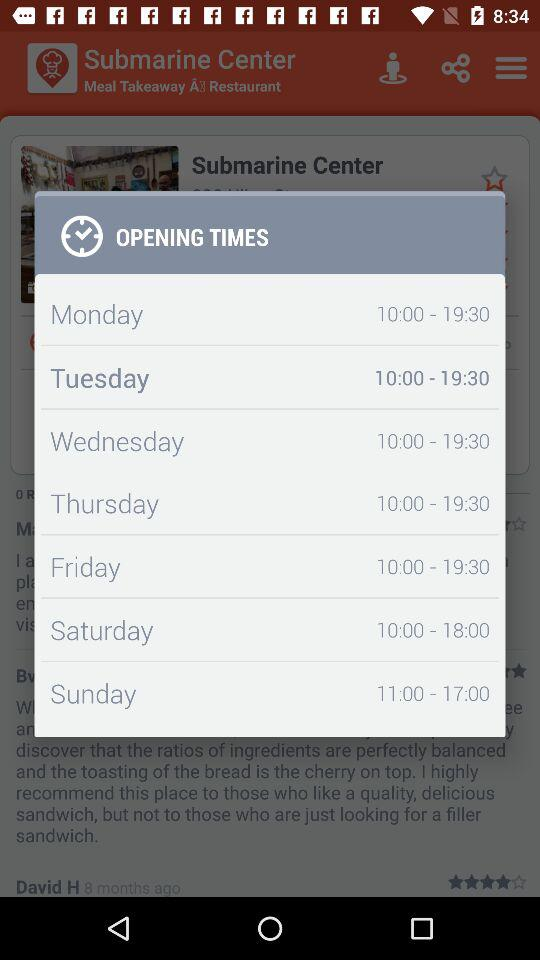Which day has the earliest closing time?
Answer the question using a single word or phrase. Sunday 